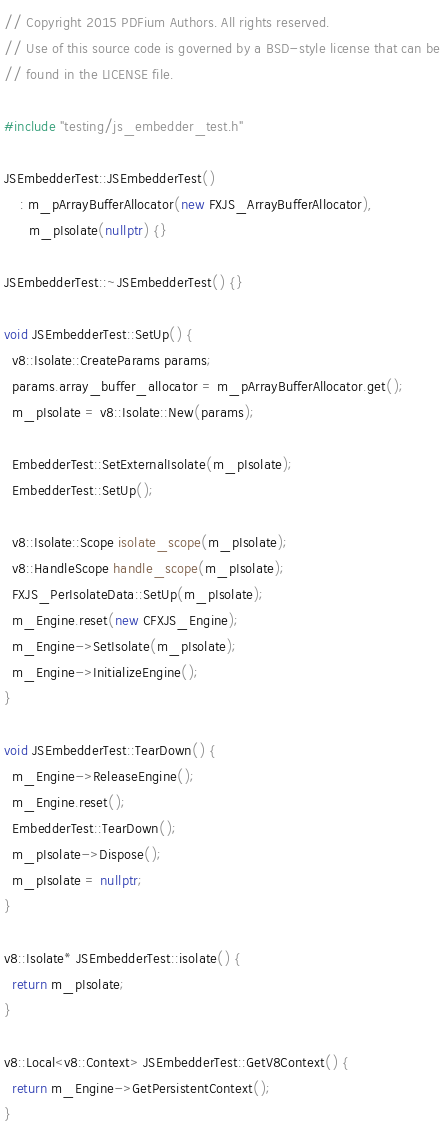<code> <loc_0><loc_0><loc_500><loc_500><_C++_>// Copyright 2015 PDFium Authors. All rights reserved.
// Use of this source code is governed by a BSD-style license that can be
// found in the LICENSE file.

#include "testing/js_embedder_test.h"

JSEmbedderTest::JSEmbedderTest()
    : m_pArrayBufferAllocator(new FXJS_ArrayBufferAllocator),
      m_pIsolate(nullptr) {}

JSEmbedderTest::~JSEmbedderTest() {}

void JSEmbedderTest::SetUp() {
  v8::Isolate::CreateParams params;
  params.array_buffer_allocator = m_pArrayBufferAllocator.get();
  m_pIsolate = v8::Isolate::New(params);

  EmbedderTest::SetExternalIsolate(m_pIsolate);
  EmbedderTest::SetUp();

  v8::Isolate::Scope isolate_scope(m_pIsolate);
  v8::HandleScope handle_scope(m_pIsolate);
  FXJS_PerIsolateData::SetUp(m_pIsolate);
  m_Engine.reset(new CFXJS_Engine);
  m_Engine->SetIsolate(m_pIsolate);
  m_Engine->InitializeEngine();
}

void JSEmbedderTest::TearDown() {
  m_Engine->ReleaseEngine();
  m_Engine.reset();
  EmbedderTest::TearDown();
  m_pIsolate->Dispose();
  m_pIsolate = nullptr;
}

v8::Isolate* JSEmbedderTest::isolate() {
  return m_pIsolate;
}

v8::Local<v8::Context> JSEmbedderTest::GetV8Context() {
  return m_Engine->GetPersistentContext();
}
</code> 